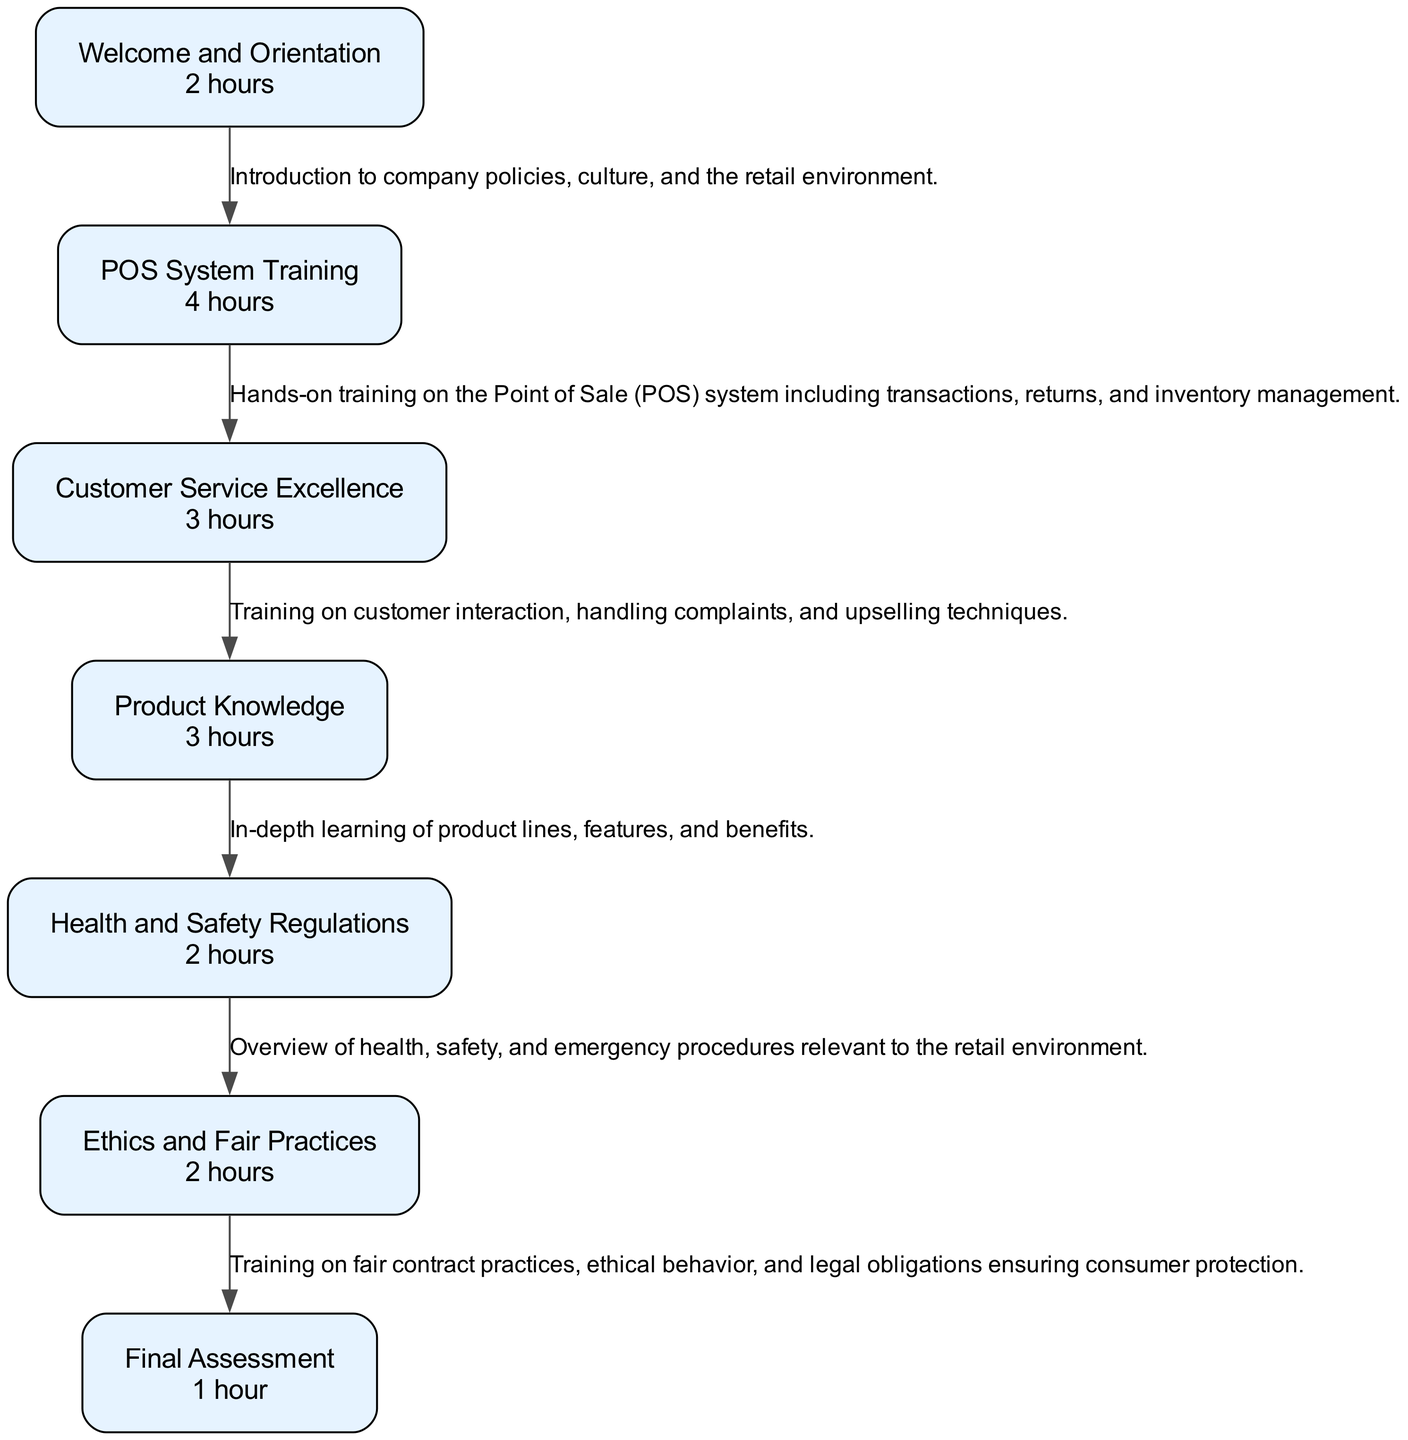What is the duration of the Welcome and Orientation training? The diagram specifies that the duration for Welcome and Orientation, which is the first training element, is 2 hours.
Answer: 2 hours How many training sessions are there in total? By counting the elements in the diagram, we see there are 7 training sessions or nodes listed, starting from Welcome and Orientation to the Final Assessment.
Answer: 7 What is the last training session before the Final Assessment? Tracing the flow of the diagram, the last training session leading to Final Assessment is Ethics and Fair Practices, which is node 6.
Answer: Ethics and Fair Practices What is the duration of the Product Knowledge training? In the diagram, the duration of the Product Knowledge session is indicated as 3 hours.
Answer: 3 hours What training session focuses on customer interaction? The diagram indicates that the Customer Service Excellence training focuses on customer interaction, as described in its details.
Answer: Customer Service Excellence Which node has the training description "Evaluation of knowledge and skills acquired during the training"? Looking at the nodes, the description clearly belongs to the Final Assessment, which is the last node in the training sequence.
Answer: Final Assessment How many hours does the Ethics and Fair Practices training take? The diagram shows that Ethics and Fair Practices training takes 2 hours, as noted in its duration data.
Answer: 2 hours What is the first step in the training schedule? The first step in the training schedule, as represented in the diagram, is Welcome and Orientation, which is the initial node.
Answer: Welcome and Orientation What is the average duration of the training sessions? To find the average duration, add each session's duration (2+4+3+3+2+2+1 = 17) and divide by the number of sessions (7), resulting in an average of about 2.43 hours.
Answer: 2.43 hours 